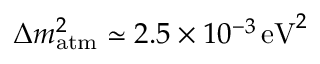Convert formula to latex. <formula><loc_0><loc_0><loc_500><loc_500>\Delta m _ { a t m } ^ { 2 } \simeq 2 . 5 \times 1 0 ^ { - 3 } \, { e V } ^ { 2 }</formula> 